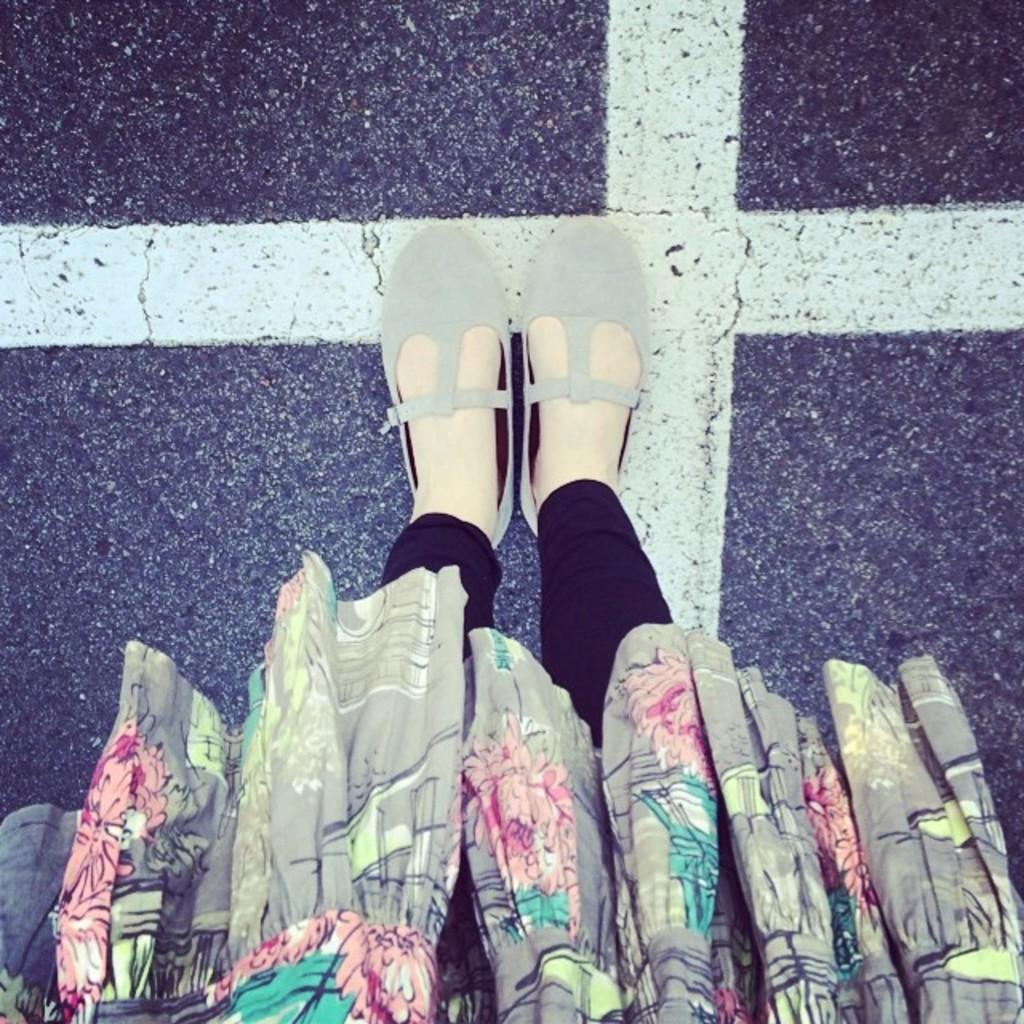What part of a person can be seen in the image? There are legs of a person visible in the image. Where are the legs located in relation to the ground? The legs are on the ground. What type of bird can be seen perched on the grape in the image? There is no bird or grape present in the image; it only shows the legs of a person on the ground. 